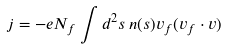<formula> <loc_0><loc_0><loc_500><loc_500>j = - e N _ { f } \int d ^ { 2 } s \, n ( s ) { v } _ { f } ( { v } _ { f } \cdot { v } )</formula> 